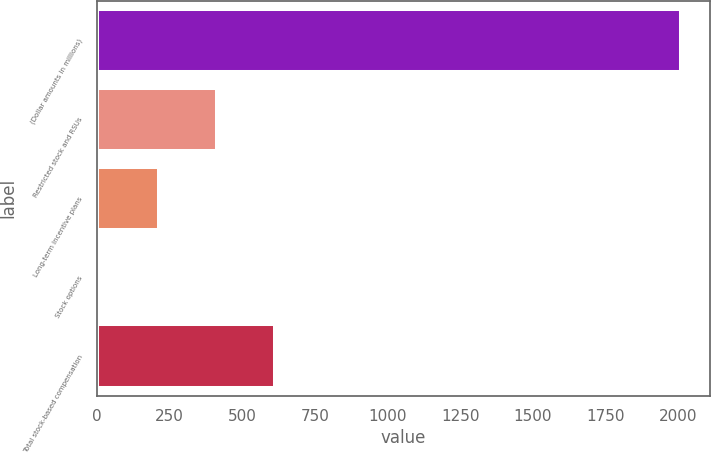Convert chart. <chart><loc_0><loc_0><loc_500><loc_500><bar_chart><fcel>(Dollar amounts in millions)<fcel>Restricted stock and RSUs<fcel>Long-term incentive plans<fcel>Stock options<fcel>Total stock-based compensation<nl><fcel>2009<fcel>411.4<fcel>211.7<fcel>12<fcel>611.1<nl></chart> 